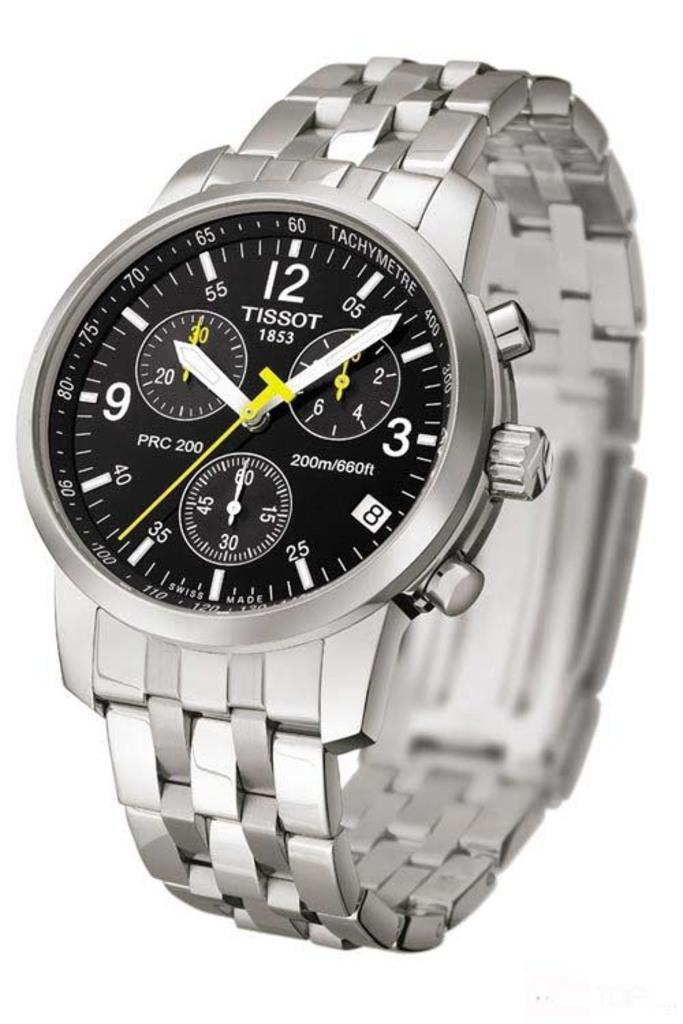<image>
Offer a succinct explanation of the picture presented. A Tissot watch has a yellow second hand and says 1853 on the face. 